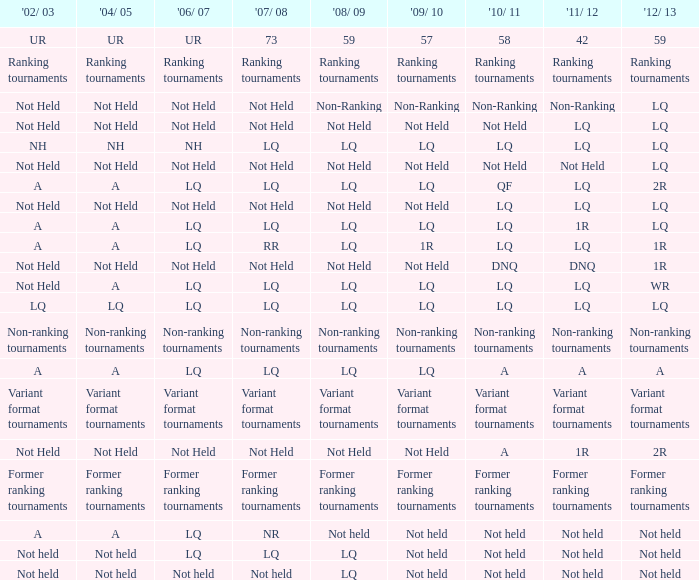Name the 2011/12 with 2008/09 of not held with 2010/11 of not held LQ, Not Held, Not held. 